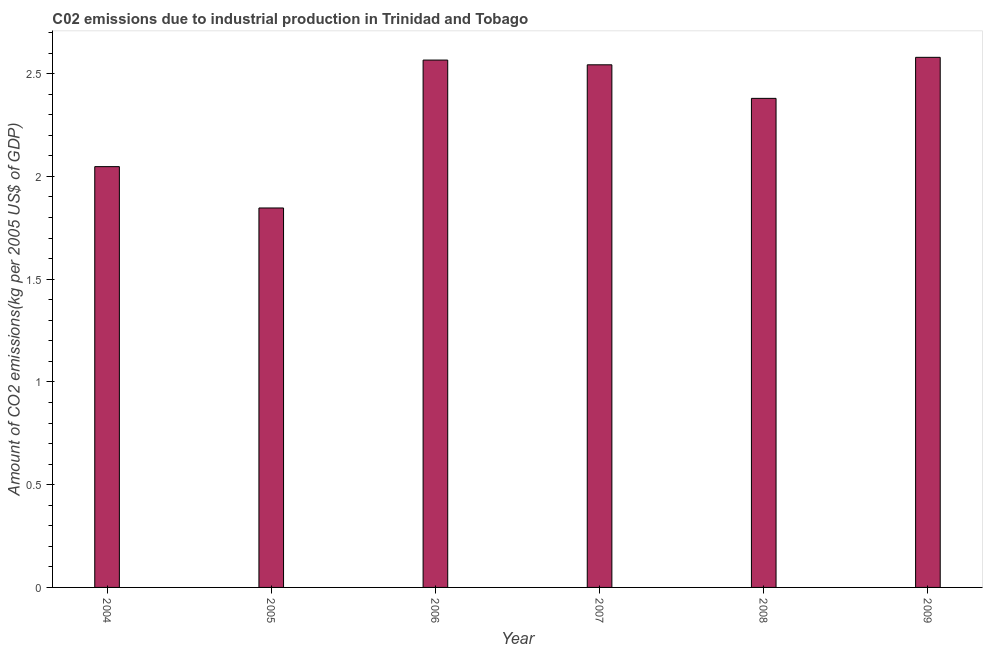Does the graph contain grids?
Offer a terse response. No. What is the title of the graph?
Your answer should be very brief. C02 emissions due to industrial production in Trinidad and Tobago. What is the label or title of the Y-axis?
Your response must be concise. Amount of CO2 emissions(kg per 2005 US$ of GDP). What is the amount of co2 emissions in 2007?
Your answer should be compact. 2.54. Across all years, what is the maximum amount of co2 emissions?
Make the answer very short. 2.58. Across all years, what is the minimum amount of co2 emissions?
Your answer should be very brief. 1.85. In which year was the amount of co2 emissions maximum?
Your answer should be compact. 2009. What is the sum of the amount of co2 emissions?
Your response must be concise. 13.96. What is the difference between the amount of co2 emissions in 2006 and 2008?
Offer a terse response. 0.19. What is the average amount of co2 emissions per year?
Your response must be concise. 2.33. What is the median amount of co2 emissions?
Your answer should be very brief. 2.46. In how many years, is the amount of co2 emissions greater than 2.1 kg per 2005 US$ of GDP?
Offer a terse response. 4. Do a majority of the years between 2008 and 2007 (inclusive) have amount of co2 emissions greater than 0.5 kg per 2005 US$ of GDP?
Your answer should be very brief. No. What is the ratio of the amount of co2 emissions in 2004 to that in 2005?
Offer a terse response. 1.11. Is the difference between the amount of co2 emissions in 2005 and 2006 greater than the difference between any two years?
Give a very brief answer. No. What is the difference between the highest and the second highest amount of co2 emissions?
Provide a succinct answer. 0.01. Is the sum of the amount of co2 emissions in 2006 and 2008 greater than the maximum amount of co2 emissions across all years?
Provide a succinct answer. Yes. What is the difference between the highest and the lowest amount of co2 emissions?
Provide a short and direct response. 0.73. In how many years, is the amount of co2 emissions greater than the average amount of co2 emissions taken over all years?
Ensure brevity in your answer.  4. Are all the bars in the graph horizontal?
Your response must be concise. No. How many years are there in the graph?
Your response must be concise. 6. What is the difference between two consecutive major ticks on the Y-axis?
Your answer should be very brief. 0.5. What is the Amount of CO2 emissions(kg per 2005 US$ of GDP) in 2004?
Keep it short and to the point. 2.05. What is the Amount of CO2 emissions(kg per 2005 US$ of GDP) in 2005?
Your answer should be very brief. 1.85. What is the Amount of CO2 emissions(kg per 2005 US$ of GDP) in 2006?
Your response must be concise. 2.57. What is the Amount of CO2 emissions(kg per 2005 US$ of GDP) in 2007?
Ensure brevity in your answer.  2.54. What is the Amount of CO2 emissions(kg per 2005 US$ of GDP) in 2008?
Offer a very short reply. 2.38. What is the Amount of CO2 emissions(kg per 2005 US$ of GDP) of 2009?
Your answer should be compact. 2.58. What is the difference between the Amount of CO2 emissions(kg per 2005 US$ of GDP) in 2004 and 2005?
Ensure brevity in your answer.  0.2. What is the difference between the Amount of CO2 emissions(kg per 2005 US$ of GDP) in 2004 and 2006?
Your answer should be very brief. -0.52. What is the difference between the Amount of CO2 emissions(kg per 2005 US$ of GDP) in 2004 and 2007?
Offer a very short reply. -0.5. What is the difference between the Amount of CO2 emissions(kg per 2005 US$ of GDP) in 2004 and 2008?
Make the answer very short. -0.33. What is the difference between the Amount of CO2 emissions(kg per 2005 US$ of GDP) in 2004 and 2009?
Make the answer very short. -0.53. What is the difference between the Amount of CO2 emissions(kg per 2005 US$ of GDP) in 2005 and 2006?
Make the answer very short. -0.72. What is the difference between the Amount of CO2 emissions(kg per 2005 US$ of GDP) in 2005 and 2007?
Your answer should be compact. -0.7. What is the difference between the Amount of CO2 emissions(kg per 2005 US$ of GDP) in 2005 and 2008?
Your answer should be compact. -0.53. What is the difference between the Amount of CO2 emissions(kg per 2005 US$ of GDP) in 2005 and 2009?
Your answer should be very brief. -0.73. What is the difference between the Amount of CO2 emissions(kg per 2005 US$ of GDP) in 2006 and 2007?
Give a very brief answer. 0.02. What is the difference between the Amount of CO2 emissions(kg per 2005 US$ of GDP) in 2006 and 2008?
Offer a very short reply. 0.19. What is the difference between the Amount of CO2 emissions(kg per 2005 US$ of GDP) in 2006 and 2009?
Ensure brevity in your answer.  -0.01. What is the difference between the Amount of CO2 emissions(kg per 2005 US$ of GDP) in 2007 and 2008?
Ensure brevity in your answer.  0.16. What is the difference between the Amount of CO2 emissions(kg per 2005 US$ of GDP) in 2007 and 2009?
Your answer should be very brief. -0.04. What is the difference between the Amount of CO2 emissions(kg per 2005 US$ of GDP) in 2008 and 2009?
Provide a succinct answer. -0.2. What is the ratio of the Amount of CO2 emissions(kg per 2005 US$ of GDP) in 2004 to that in 2005?
Your response must be concise. 1.11. What is the ratio of the Amount of CO2 emissions(kg per 2005 US$ of GDP) in 2004 to that in 2006?
Offer a very short reply. 0.8. What is the ratio of the Amount of CO2 emissions(kg per 2005 US$ of GDP) in 2004 to that in 2007?
Give a very brief answer. 0.81. What is the ratio of the Amount of CO2 emissions(kg per 2005 US$ of GDP) in 2004 to that in 2008?
Offer a terse response. 0.86. What is the ratio of the Amount of CO2 emissions(kg per 2005 US$ of GDP) in 2004 to that in 2009?
Ensure brevity in your answer.  0.79. What is the ratio of the Amount of CO2 emissions(kg per 2005 US$ of GDP) in 2005 to that in 2006?
Your answer should be compact. 0.72. What is the ratio of the Amount of CO2 emissions(kg per 2005 US$ of GDP) in 2005 to that in 2007?
Provide a succinct answer. 0.73. What is the ratio of the Amount of CO2 emissions(kg per 2005 US$ of GDP) in 2005 to that in 2008?
Provide a succinct answer. 0.78. What is the ratio of the Amount of CO2 emissions(kg per 2005 US$ of GDP) in 2005 to that in 2009?
Keep it short and to the point. 0.72. What is the ratio of the Amount of CO2 emissions(kg per 2005 US$ of GDP) in 2006 to that in 2008?
Offer a very short reply. 1.08. What is the ratio of the Amount of CO2 emissions(kg per 2005 US$ of GDP) in 2007 to that in 2008?
Ensure brevity in your answer.  1.07. What is the ratio of the Amount of CO2 emissions(kg per 2005 US$ of GDP) in 2007 to that in 2009?
Keep it short and to the point. 0.99. What is the ratio of the Amount of CO2 emissions(kg per 2005 US$ of GDP) in 2008 to that in 2009?
Offer a terse response. 0.92. 